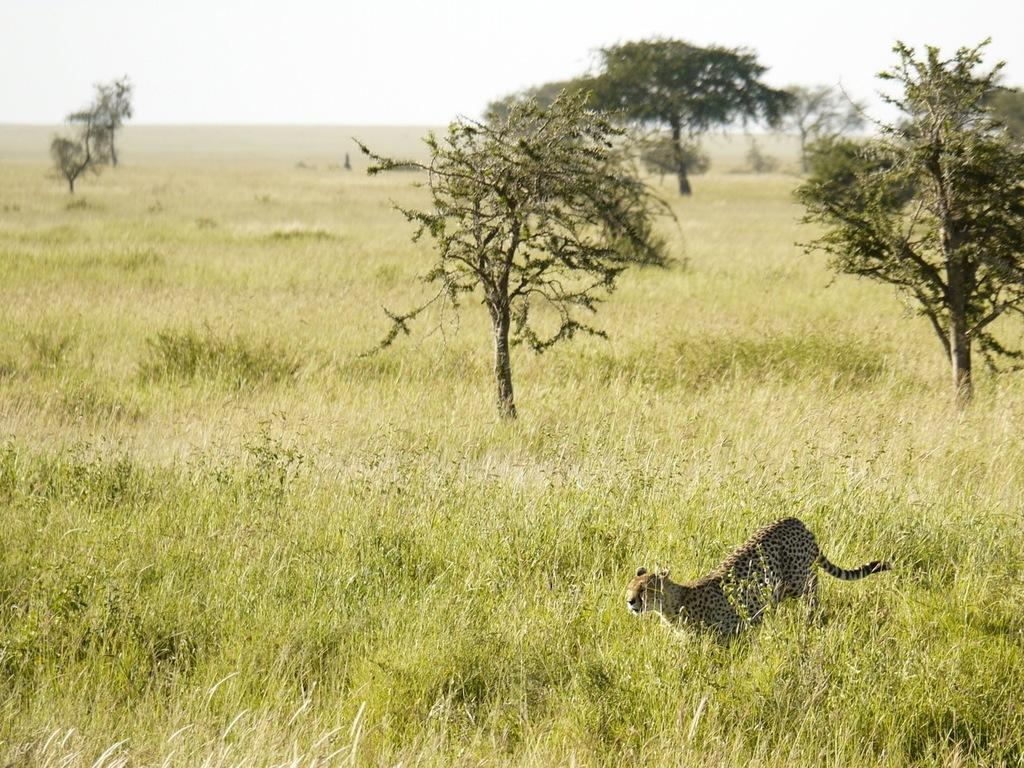What type of environment is shown in the image? The image is an outside view. What type of vegetation can be seen in the image? There is grass and trees visible in the image. What animal is present in the image? A cheetah is running in the image. In which direction is the cheetah running? The cheetah is running from the right side to the left side. What is visible at the top of the image? The sky is visible at the top of the image. How many boys are shaking hands in the image? There are no boys or handshakes present in the image; it features a cheetah running in an outdoor environment. 